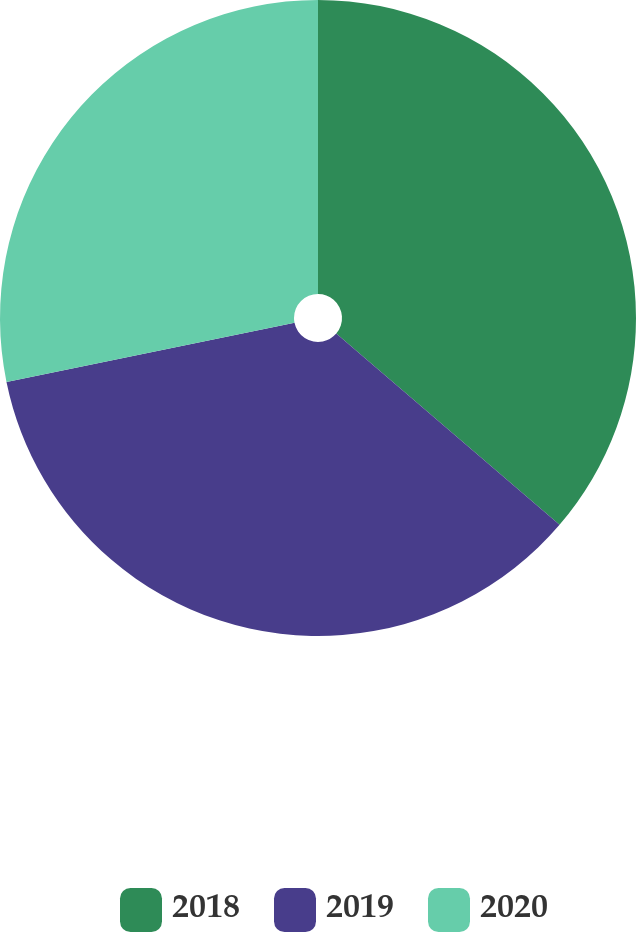<chart> <loc_0><loc_0><loc_500><loc_500><pie_chart><fcel>2018<fcel>2019<fcel>2020<nl><fcel>36.27%<fcel>35.51%<fcel>28.22%<nl></chart> 